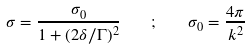<formula> <loc_0><loc_0><loc_500><loc_500>\sigma = \frac { \sigma _ { 0 } } { 1 + ( 2 \delta / \Gamma ) ^ { 2 } } \quad ; \quad \sigma _ { 0 } = \frac { 4 \pi } { k ^ { 2 } }</formula> 